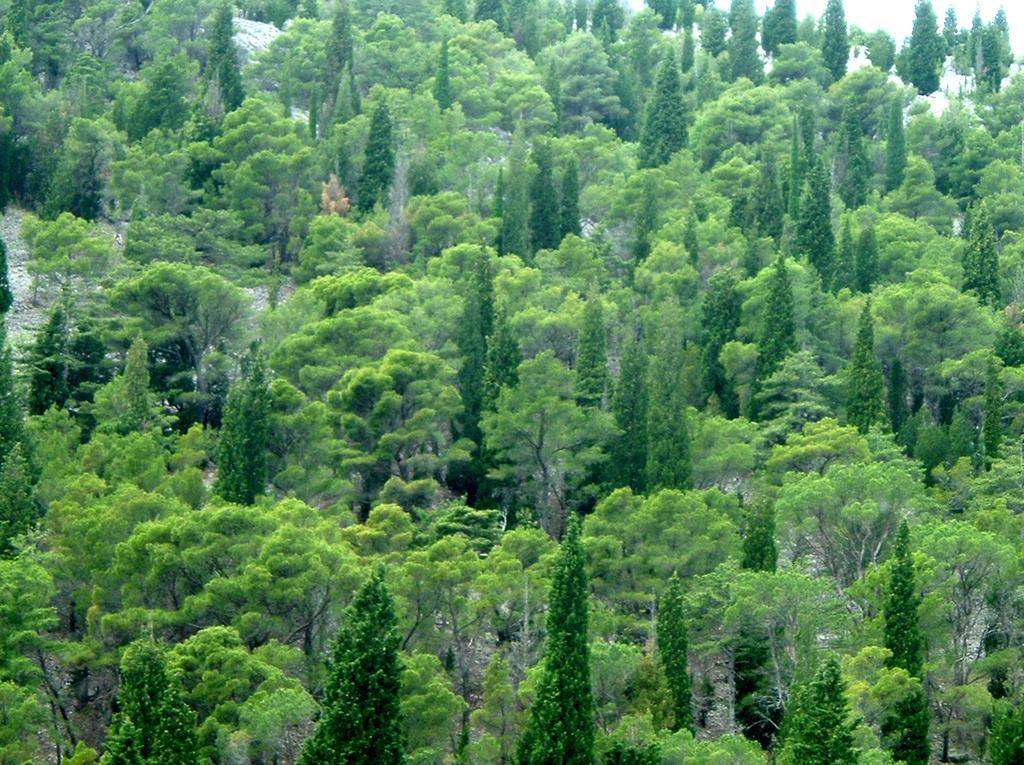How would you summarize this image in a sentence or two? In this image we can see trees. 